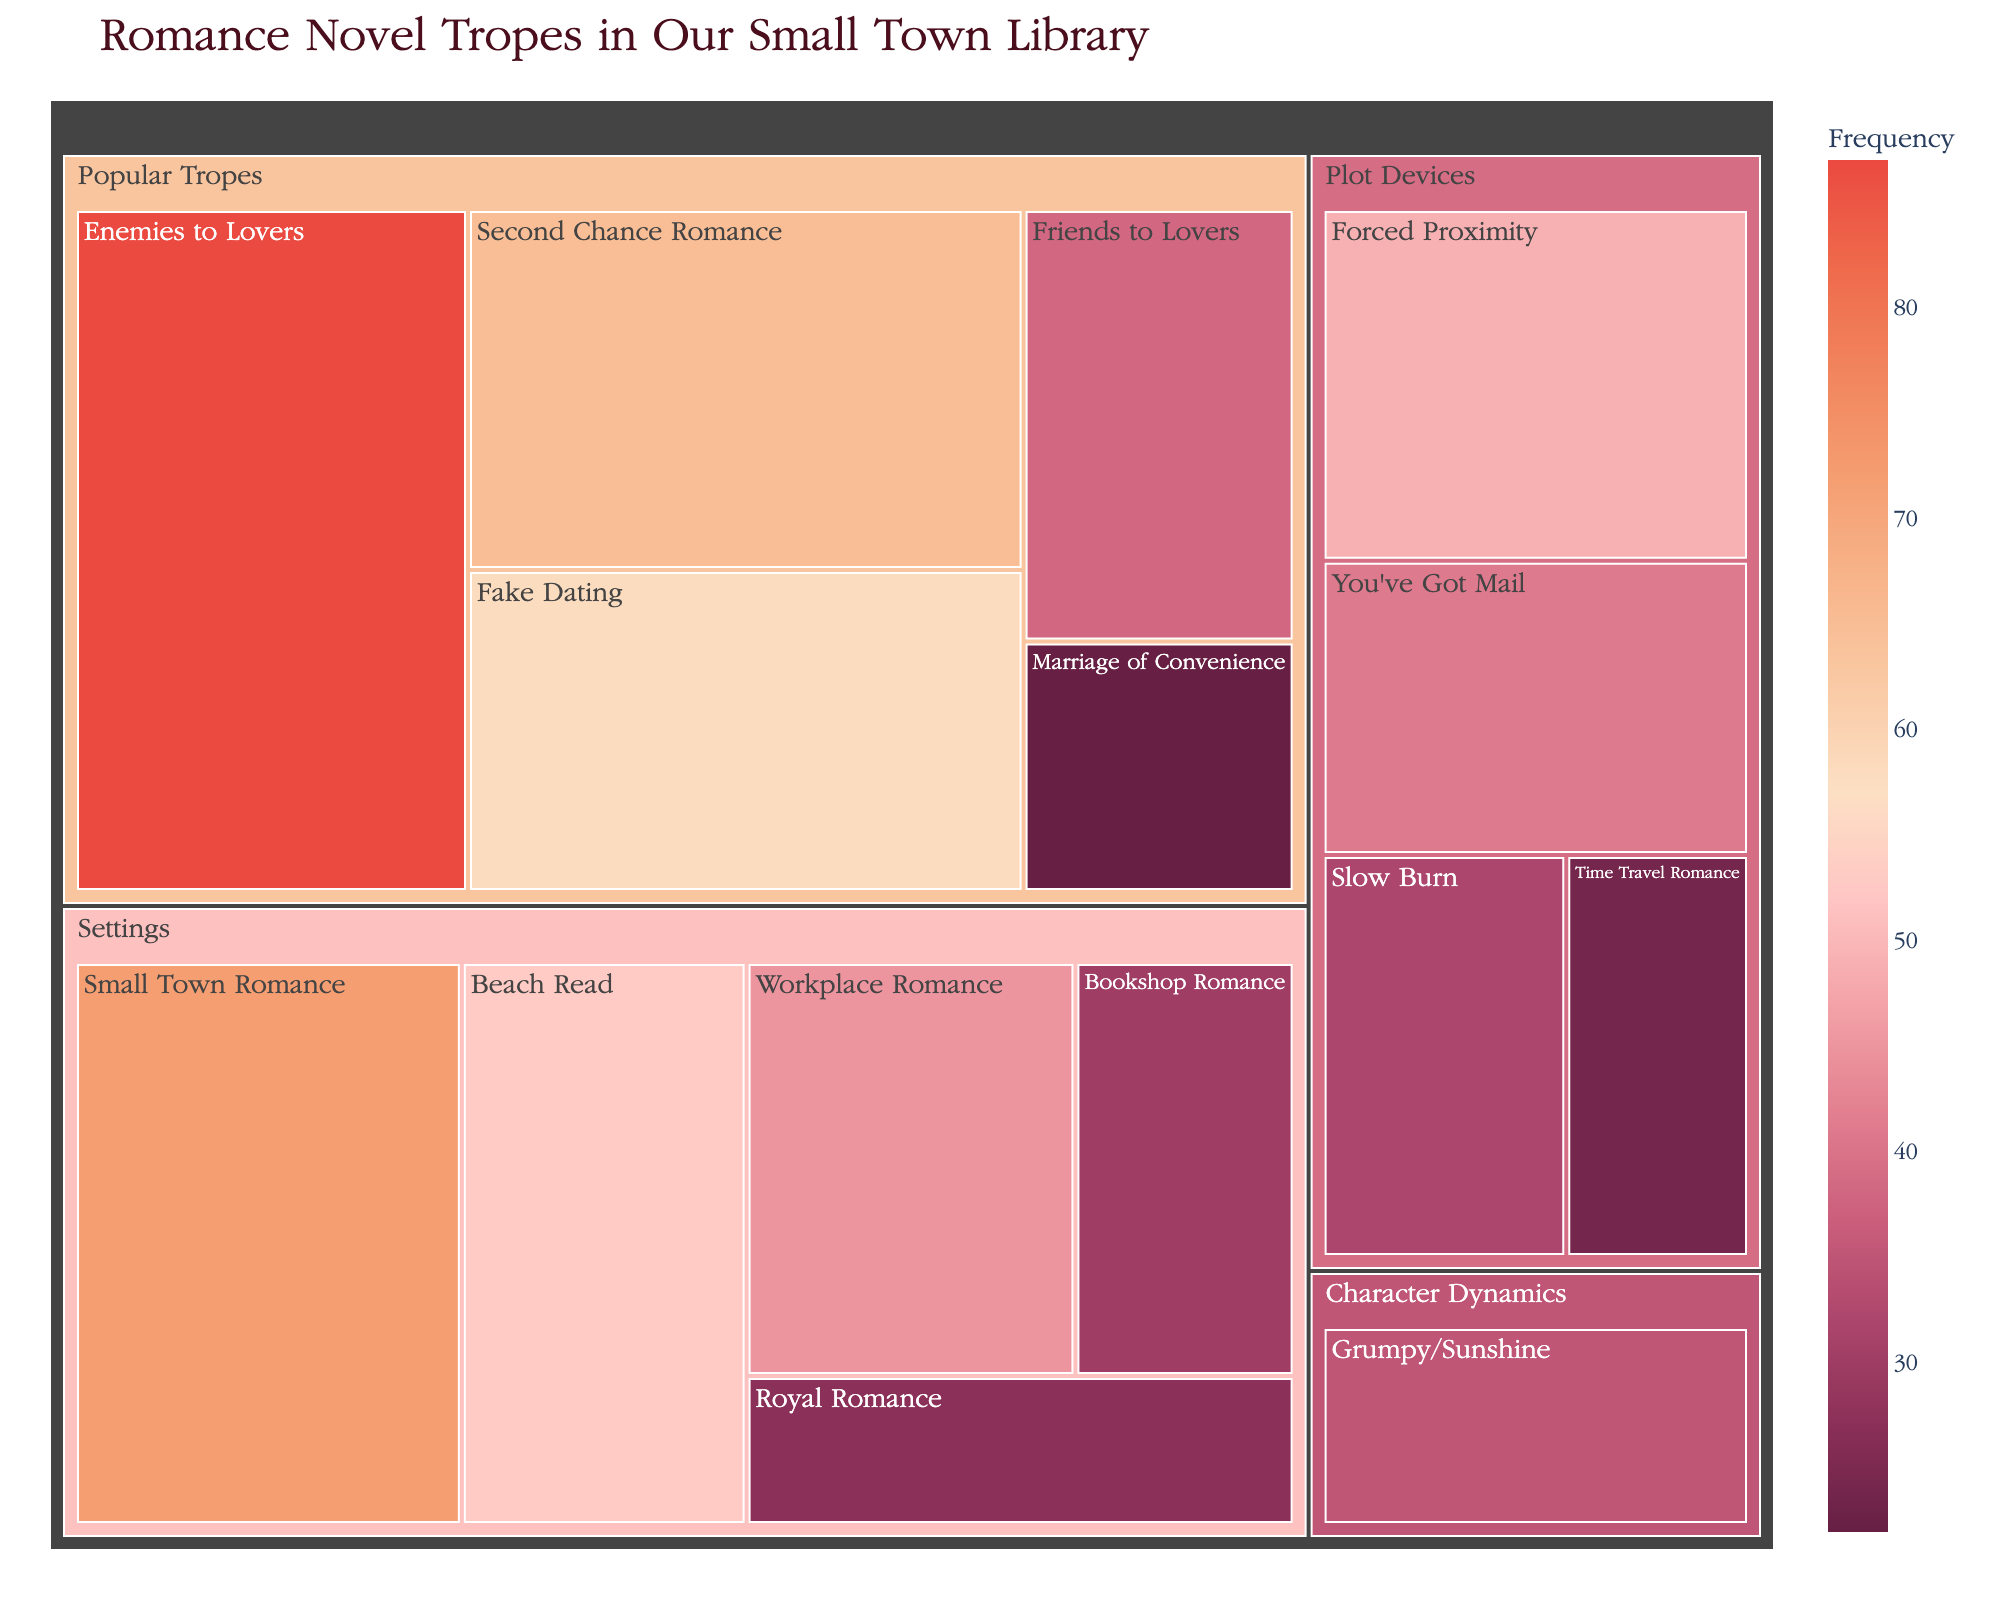Which trope is the most prevalent in the library's collection? The trope with the highest frequency is displayed prominently in the treemap. The largest tile corresponds to "Enemies to Lovers" under the "Popular Tropes" category, with a frequency of 87.
Answer: Enemies to Lovers How many tropes are there in the "Settings" category and what is their combined frequency? The "Settings" category includes "Small Town Romance," "Beach Read," "Workplace Romance," "Bookshop Romance," and "Royal Romance." Their frequencies are 72, 53, 45, 30, and 27 respectively. The combined frequency is 72 + 53 + 45 + 30 + 27 = 227.
Answer: 5 tropes, combined frequency is 227 Which category has the fewest tropes, and how many does it have? By examining the tiles within each color-coded section, we can see that "Character Dynamics" has the fewest tropes, featuring only one: "Grumpy/Sunshine" with a frequency of 35.
Answer: Character Dynamics, 1 trope Is "Fake Dating" more frequent than "Friends to Lovers"? We compare the frequencies of these two tropes. "Fake Dating" has a frequency of 58, while "Friends to Lovers" has a frequency of 38. Since 58 > 38, "Fake Dating" is more frequent.
Answer: Yes What is the average frequency of tropes in the "Plot Devices" category? The "Plot Devices" category includes "Forced Proximity," "You've Got Mail," "Slow Burn," and "Time Travel Romance" with frequencies 49, 41, 32, and 24 respectively. The combined frequency is 49 + 41 + 32 + 24 = 146. The average frequency is 146 / 4 = 36.5.
Answer: 36.5 Which trope has the lowest frequency, and which category does it belong to? The trope with the lowest frequency can be found by looking for the smallest tile in the treemap. "Marriage of Convenience" has the lowest frequency of 22 and it belongs to the "Popular Tropes" category.
Answer: Marriage of Convenience, Popular Tropes What is the difference in frequency between the most and the least prevalent tropes? The most prevalent trope, "Enemies to Lovers," has a frequency of 87. The least prevalent, "Marriage of Convenience," has a frequency of 22. The difference is 87 - 22 = 65.
Answer: 65 Which two "Popular Tropes" have the closest frequencies, and what are their values? "Second Chance Romance" and "Fake Dating" are the "Popular Tropes" with the closest frequencies. Their frequencies are 65 and 58 respectively.
Answer: Second Chance Romance (65) and Fake Dating (58) Overall, which category seems to dominate in terms of total frequency? We need to sum up the frequencies of each category. The total frequencies for "Popular Tropes," "Settings," "Plot Devices," and "Character Dynamics" are: 87 + 65 + 58 + 38 + 22 = 270, 72 + 53 + 45 + 30 + 27 = 227, 49 + 41 + 32 + 24 = 146, and 35 respectively. "Popular Tropes" has the highest total frequency of 270.
Answer: Popular Tropes 